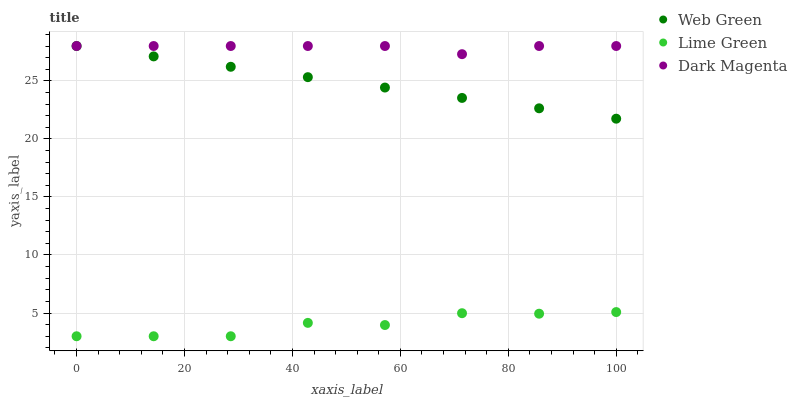Does Lime Green have the minimum area under the curve?
Answer yes or no. Yes. Does Dark Magenta have the maximum area under the curve?
Answer yes or no. Yes. Does Web Green have the minimum area under the curve?
Answer yes or no. No. Does Web Green have the maximum area under the curve?
Answer yes or no. No. Is Web Green the smoothest?
Answer yes or no. Yes. Is Lime Green the roughest?
Answer yes or no. Yes. Is Dark Magenta the smoothest?
Answer yes or no. No. Is Dark Magenta the roughest?
Answer yes or no. No. Does Lime Green have the lowest value?
Answer yes or no. Yes. Does Web Green have the lowest value?
Answer yes or no. No. Does Web Green have the highest value?
Answer yes or no. Yes. Is Lime Green less than Web Green?
Answer yes or no. Yes. Is Dark Magenta greater than Lime Green?
Answer yes or no. Yes. Does Web Green intersect Dark Magenta?
Answer yes or no. Yes. Is Web Green less than Dark Magenta?
Answer yes or no. No. Is Web Green greater than Dark Magenta?
Answer yes or no. No. Does Lime Green intersect Web Green?
Answer yes or no. No. 